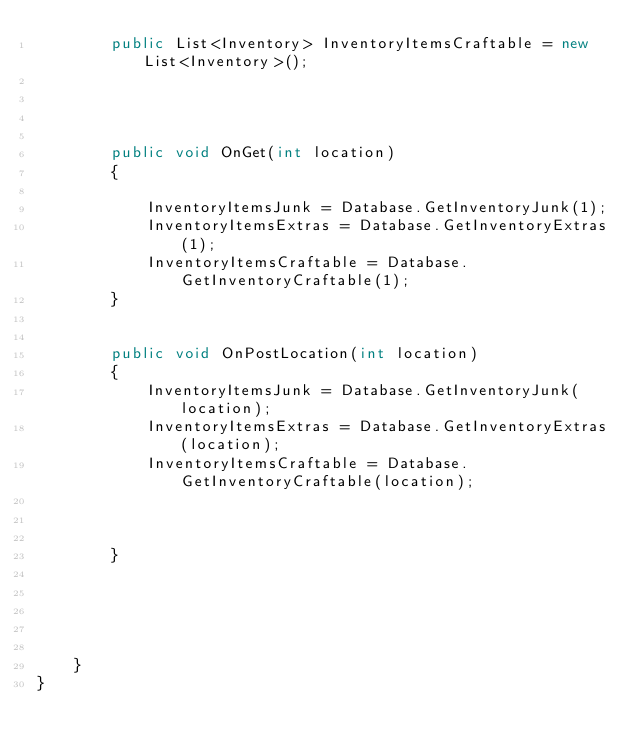Convert code to text. <code><loc_0><loc_0><loc_500><loc_500><_C#_>        public List<Inventory> InventoryItemsCraftable = new List<Inventory>();




        public void OnGet(int location)
        {

            InventoryItemsJunk = Database.GetInventoryJunk(1);
            InventoryItemsExtras = Database.GetInventoryExtras(1);
            InventoryItemsCraftable = Database.GetInventoryCraftable(1);
        }


        public void OnPostLocation(int location)
        {
            InventoryItemsJunk = Database.GetInventoryJunk(location);
            InventoryItemsExtras = Database.GetInventoryExtras(location);
            InventoryItemsCraftable = Database.GetInventoryCraftable(location);



        }





    }
}
</code> 